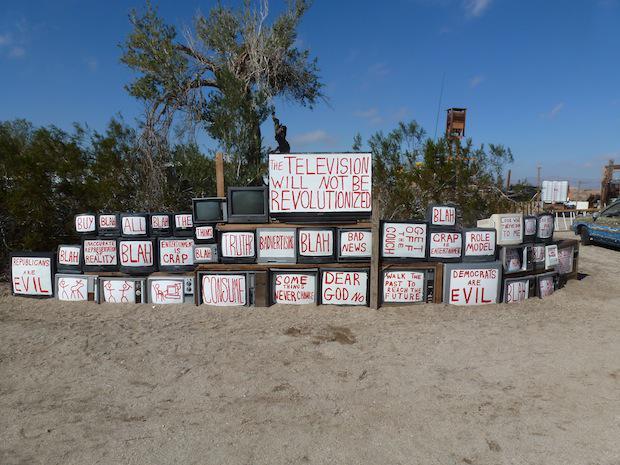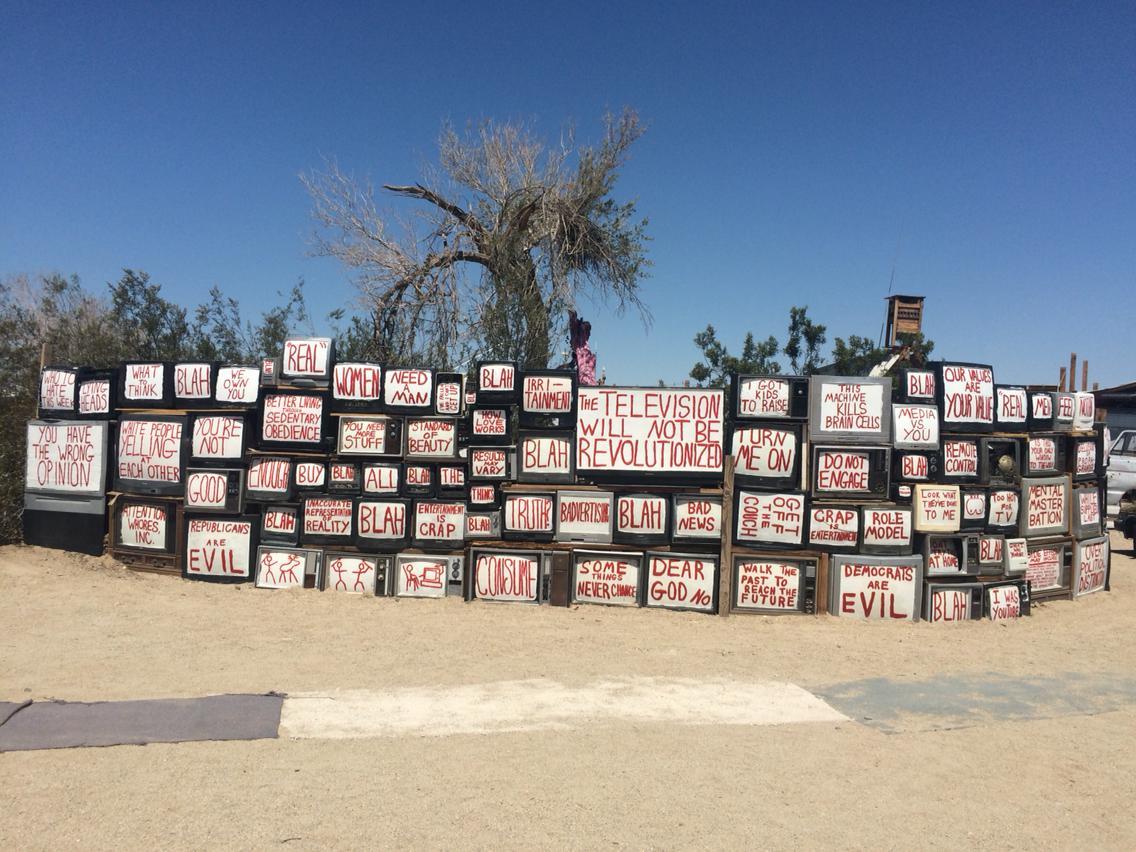The first image is the image on the left, the second image is the image on the right. Analyze the images presented: Is the assertion "A screen in the lower right says that democrats are evil, in at least one of the images." valid? Answer yes or no. Yes. The first image is the image on the left, the second image is the image on the right. Examine the images to the left and right. Is the description "in at least on of the pics, the sign that says the television will not be revolutionized is the highest sign in the photo" accurate? Answer yes or no. Yes. 